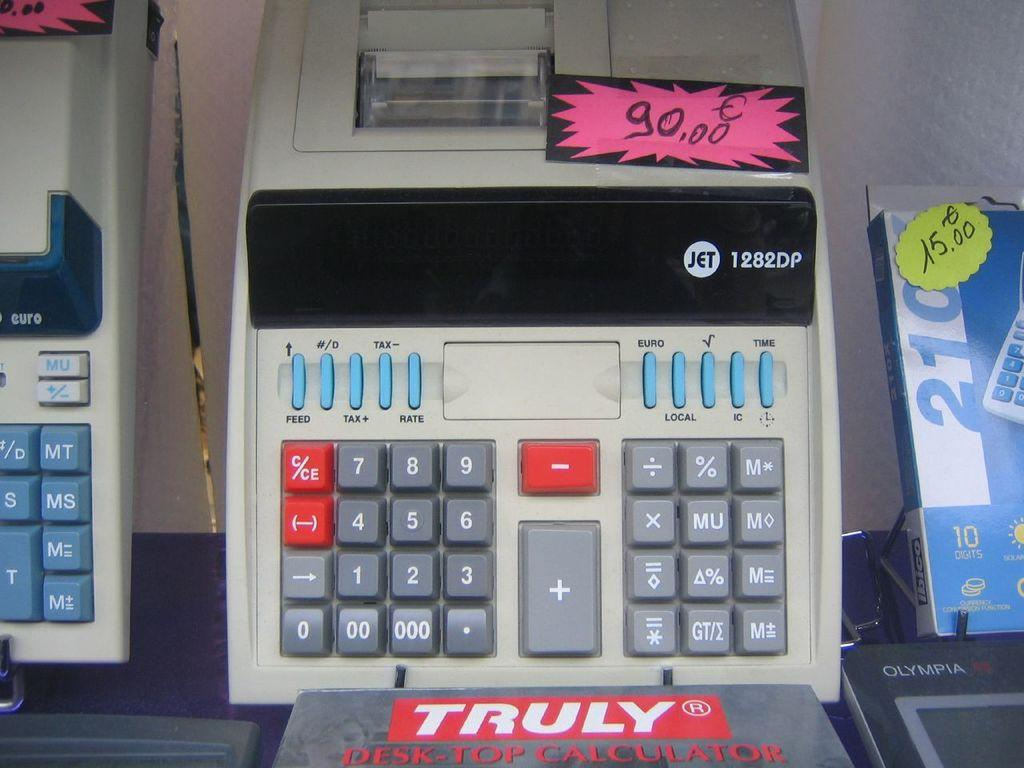<image>
Give a short and clear explanation of the subsequent image. An adding machine made by Jet has a 90.00 price tag. 